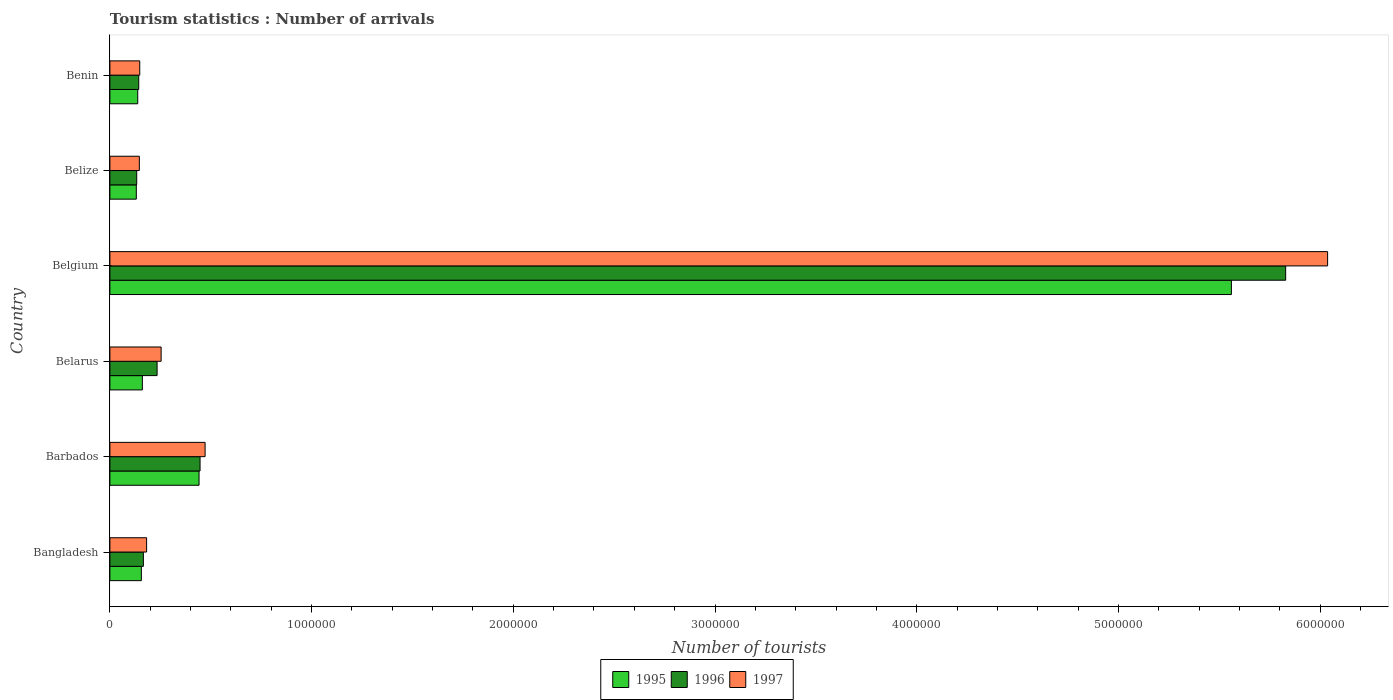How many different coloured bars are there?
Provide a succinct answer. 3. How many groups of bars are there?
Your answer should be compact. 6. Are the number of bars per tick equal to the number of legend labels?
Give a very brief answer. Yes. How many bars are there on the 2nd tick from the top?
Give a very brief answer. 3. What is the label of the 5th group of bars from the top?
Offer a very short reply. Barbados. In how many cases, is the number of bars for a given country not equal to the number of legend labels?
Provide a short and direct response. 0. What is the number of tourist arrivals in 1997 in Benin?
Keep it short and to the point. 1.48e+05. Across all countries, what is the maximum number of tourist arrivals in 1995?
Keep it short and to the point. 5.56e+06. Across all countries, what is the minimum number of tourist arrivals in 1997?
Your answer should be compact. 1.46e+05. In which country was the number of tourist arrivals in 1995 minimum?
Your answer should be very brief. Belize. What is the total number of tourist arrivals in 1996 in the graph?
Your response must be concise. 6.95e+06. What is the difference between the number of tourist arrivals in 1996 in Barbados and that in Belize?
Your answer should be very brief. 3.14e+05. What is the difference between the number of tourist arrivals in 1996 in Bangladesh and the number of tourist arrivals in 1995 in Belgium?
Your answer should be very brief. -5.39e+06. What is the average number of tourist arrivals in 1996 per country?
Ensure brevity in your answer.  1.16e+06. What is the difference between the number of tourist arrivals in 1997 and number of tourist arrivals in 1996 in Belize?
Give a very brief answer. 1.30e+04. In how many countries, is the number of tourist arrivals in 1996 greater than 800000 ?
Provide a short and direct response. 1. What is the ratio of the number of tourist arrivals in 1996 in Bangladesh to that in Belize?
Your response must be concise. 1.25. Is the difference between the number of tourist arrivals in 1997 in Bangladesh and Belarus greater than the difference between the number of tourist arrivals in 1996 in Bangladesh and Belarus?
Offer a terse response. No. What is the difference between the highest and the second highest number of tourist arrivals in 1995?
Your answer should be compact. 5.12e+06. What is the difference between the highest and the lowest number of tourist arrivals in 1997?
Your answer should be very brief. 5.89e+06. In how many countries, is the number of tourist arrivals in 1997 greater than the average number of tourist arrivals in 1997 taken over all countries?
Make the answer very short. 1. Is the sum of the number of tourist arrivals in 1995 in Bangladesh and Belgium greater than the maximum number of tourist arrivals in 1996 across all countries?
Keep it short and to the point. No. What does the 3rd bar from the top in Belgium represents?
Offer a very short reply. 1995. What does the 2nd bar from the bottom in Benin represents?
Make the answer very short. 1996. How many bars are there?
Ensure brevity in your answer.  18. How many countries are there in the graph?
Ensure brevity in your answer.  6. Are the values on the major ticks of X-axis written in scientific E-notation?
Provide a succinct answer. No. Where does the legend appear in the graph?
Make the answer very short. Bottom center. What is the title of the graph?
Provide a short and direct response. Tourism statistics : Number of arrivals. What is the label or title of the X-axis?
Offer a very short reply. Number of tourists. What is the label or title of the Y-axis?
Your answer should be compact. Country. What is the Number of tourists in 1995 in Bangladesh?
Offer a very short reply. 1.56e+05. What is the Number of tourists of 1996 in Bangladesh?
Offer a terse response. 1.66e+05. What is the Number of tourists of 1997 in Bangladesh?
Keep it short and to the point. 1.82e+05. What is the Number of tourists of 1995 in Barbados?
Give a very brief answer. 4.42e+05. What is the Number of tourists of 1996 in Barbados?
Your answer should be very brief. 4.47e+05. What is the Number of tourists of 1997 in Barbados?
Give a very brief answer. 4.72e+05. What is the Number of tourists in 1995 in Belarus?
Provide a succinct answer. 1.61e+05. What is the Number of tourists in 1996 in Belarus?
Your answer should be compact. 2.34e+05. What is the Number of tourists in 1997 in Belarus?
Your answer should be very brief. 2.54e+05. What is the Number of tourists in 1995 in Belgium?
Make the answer very short. 5.56e+06. What is the Number of tourists in 1996 in Belgium?
Your answer should be compact. 5.83e+06. What is the Number of tourists in 1997 in Belgium?
Your response must be concise. 6.04e+06. What is the Number of tourists in 1995 in Belize?
Provide a succinct answer. 1.31e+05. What is the Number of tourists of 1996 in Belize?
Make the answer very short. 1.33e+05. What is the Number of tourists of 1997 in Belize?
Offer a terse response. 1.46e+05. What is the Number of tourists in 1995 in Benin?
Ensure brevity in your answer.  1.38e+05. What is the Number of tourists in 1996 in Benin?
Provide a succinct answer. 1.43e+05. What is the Number of tourists in 1997 in Benin?
Provide a short and direct response. 1.48e+05. Across all countries, what is the maximum Number of tourists of 1995?
Give a very brief answer. 5.56e+06. Across all countries, what is the maximum Number of tourists of 1996?
Your answer should be very brief. 5.83e+06. Across all countries, what is the maximum Number of tourists of 1997?
Make the answer very short. 6.04e+06. Across all countries, what is the minimum Number of tourists of 1995?
Ensure brevity in your answer.  1.31e+05. Across all countries, what is the minimum Number of tourists of 1996?
Provide a short and direct response. 1.33e+05. Across all countries, what is the minimum Number of tourists in 1997?
Provide a succinct answer. 1.46e+05. What is the total Number of tourists in 1995 in the graph?
Your answer should be compact. 6.59e+06. What is the total Number of tourists in 1996 in the graph?
Your response must be concise. 6.95e+06. What is the total Number of tourists in 1997 in the graph?
Your response must be concise. 7.24e+06. What is the difference between the Number of tourists of 1995 in Bangladesh and that in Barbados?
Give a very brief answer. -2.86e+05. What is the difference between the Number of tourists of 1996 in Bangladesh and that in Barbados?
Your answer should be very brief. -2.81e+05. What is the difference between the Number of tourists of 1997 in Bangladesh and that in Barbados?
Ensure brevity in your answer.  -2.90e+05. What is the difference between the Number of tourists of 1995 in Bangladesh and that in Belarus?
Provide a succinct answer. -5000. What is the difference between the Number of tourists of 1996 in Bangladesh and that in Belarus?
Your answer should be very brief. -6.80e+04. What is the difference between the Number of tourists in 1997 in Bangladesh and that in Belarus?
Provide a short and direct response. -7.20e+04. What is the difference between the Number of tourists of 1995 in Bangladesh and that in Belgium?
Give a very brief answer. -5.40e+06. What is the difference between the Number of tourists of 1996 in Bangladesh and that in Belgium?
Keep it short and to the point. -5.66e+06. What is the difference between the Number of tourists in 1997 in Bangladesh and that in Belgium?
Keep it short and to the point. -5.86e+06. What is the difference between the Number of tourists of 1995 in Bangladesh and that in Belize?
Offer a very short reply. 2.50e+04. What is the difference between the Number of tourists in 1996 in Bangladesh and that in Belize?
Your answer should be compact. 3.30e+04. What is the difference between the Number of tourists in 1997 in Bangladesh and that in Belize?
Your response must be concise. 3.60e+04. What is the difference between the Number of tourists of 1995 in Bangladesh and that in Benin?
Keep it short and to the point. 1.80e+04. What is the difference between the Number of tourists of 1996 in Bangladesh and that in Benin?
Provide a succinct answer. 2.30e+04. What is the difference between the Number of tourists of 1997 in Bangladesh and that in Benin?
Provide a short and direct response. 3.40e+04. What is the difference between the Number of tourists of 1995 in Barbados and that in Belarus?
Offer a terse response. 2.81e+05. What is the difference between the Number of tourists of 1996 in Barbados and that in Belarus?
Your answer should be very brief. 2.13e+05. What is the difference between the Number of tourists of 1997 in Barbados and that in Belarus?
Make the answer very short. 2.18e+05. What is the difference between the Number of tourists in 1995 in Barbados and that in Belgium?
Your answer should be compact. -5.12e+06. What is the difference between the Number of tourists in 1996 in Barbados and that in Belgium?
Give a very brief answer. -5.38e+06. What is the difference between the Number of tourists in 1997 in Barbados and that in Belgium?
Your answer should be compact. -5.56e+06. What is the difference between the Number of tourists in 1995 in Barbados and that in Belize?
Your response must be concise. 3.11e+05. What is the difference between the Number of tourists of 1996 in Barbados and that in Belize?
Provide a succinct answer. 3.14e+05. What is the difference between the Number of tourists in 1997 in Barbados and that in Belize?
Your answer should be compact. 3.26e+05. What is the difference between the Number of tourists of 1995 in Barbados and that in Benin?
Your answer should be compact. 3.04e+05. What is the difference between the Number of tourists in 1996 in Barbados and that in Benin?
Give a very brief answer. 3.04e+05. What is the difference between the Number of tourists of 1997 in Barbados and that in Benin?
Provide a succinct answer. 3.24e+05. What is the difference between the Number of tourists in 1995 in Belarus and that in Belgium?
Keep it short and to the point. -5.40e+06. What is the difference between the Number of tourists in 1996 in Belarus and that in Belgium?
Offer a terse response. -5.60e+06. What is the difference between the Number of tourists of 1997 in Belarus and that in Belgium?
Your response must be concise. -5.78e+06. What is the difference between the Number of tourists of 1995 in Belarus and that in Belize?
Your answer should be very brief. 3.00e+04. What is the difference between the Number of tourists in 1996 in Belarus and that in Belize?
Provide a succinct answer. 1.01e+05. What is the difference between the Number of tourists in 1997 in Belarus and that in Belize?
Keep it short and to the point. 1.08e+05. What is the difference between the Number of tourists of 1995 in Belarus and that in Benin?
Keep it short and to the point. 2.30e+04. What is the difference between the Number of tourists in 1996 in Belarus and that in Benin?
Give a very brief answer. 9.10e+04. What is the difference between the Number of tourists of 1997 in Belarus and that in Benin?
Give a very brief answer. 1.06e+05. What is the difference between the Number of tourists of 1995 in Belgium and that in Belize?
Provide a succinct answer. 5.43e+06. What is the difference between the Number of tourists of 1996 in Belgium and that in Belize?
Offer a very short reply. 5.70e+06. What is the difference between the Number of tourists in 1997 in Belgium and that in Belize?
Provide a short and direct response. 5.89e+06. What is the difference between the Number of tourists in 1995 in Belgium and that in Benin?
Provide a short and direct response. 5.42e+06. What is the difference between the Number of tourists in 1996 in Belgium and that in Benin?
Offer a very short reply. 5.69e+06. What is the difference between the Number of tourists of 1997 in Belgium and that in Benin?
Provide a succinct answer. 5.89e+06. What is the difference between the Number of tourists in 1995 in Belize and that in Benin?
Offer a terse response. -7000. What is the difference between the Number of tourists of 1997 in Belize and that in Benin?
Make the answer very short. -2000. What is the difference between the Number of tourists of 1995 in Bangladesh and the Number of tourists of 1996 in Barbados?
Provide a short and direct response. -2.91e+05. What is the difference between the Number of tourists of 1995 in Bangladesh and the Number of tourists of 1997 in Barbados?
Offer a terse response. -3.16e+05. What is the difference between the Number of tourists in 1996 in Bangladesh and the Number of tourists in 1997 in Barbados?
Your response must be concise. -3.06e+05. What is the difference between the Number of tourists of 1995 in Bangladesh and the Number of tourists of 1996 in Belarus?
Offer a terse response. -7.80e+04. What is the difference between the Number of tourists in 1995 in Bangladesh and the Number of tourists in 1997 in Belarus?
Provide a short and direct response. -9.80e+04. What is the difference between the Number of tourists in 1996 in Bangladesh and the Number of tourists in 1997 in Belarus?
Your answer should be very brief. -8.80e+04. What is the difference between the Number of tourists in 1995 in Bangladesh and the Number of tourists in 1996 in Belgium?
Your answer should be very brief. -5.67e+06. What is the difference between the Number of tourists of 1995 in Bangladesh and the Number of tourists of 1997 in Belgium?
Your answer should be compact. -5.88e+06. What is the difference between the Number of tourists in 1996 in Bangladesh and the Number of tourists in 1997 in Belgium?
Your response must be concise. -5.87e+06. What is the difference between the Number of tourists of 1995 in Bangladesh and the Number of tourists of 1996 in Belize?
Keep it short and to the point. 2.30e+04. What is the difference between the Number of tourists of 1995 in Bangladesh and the Number of tourists of 1996 in Benin?
Your answer should be very brief. 1.30e+04. What is the difference between the Number of tourists in 1995 in Bangladesh and the Number of tourists in 1997 in Benin?
Make the answer very short. 8000. What is the difference between the Number of tourists of 1996 in Bangladesh and the Number of tourists of 1997 in Benin?
Your response must be concise. 1.80e+04. What is the difference between the Number of tourists of 1995 in Barbados and the Number of tourists of 1996 in Belarus?
Keep it short and to the point. 2.08e+05. What is the difference between the Number of tourists of 1995 in Barbados and the Number of tourists of 1997 in Belarus?
Your response must be concise. 1.88e+05. What is the difference between the Number of tourists of 1996 in Barbados and the Number of tourists of 1997 in Belarus?
Ensure brevity in your answer.  1.93e+05. What is the difference between the Number of tourists in 1995 in Barbados and the Number of tourists in 1996 in Belgium?
Provide a short and direct response. -5.39e+06. What is the difference between the Number of tourists of 1995 in Barbados and the Number of tourists of 1997 in Belgium?
Provide a short and direct response. -5.60e+06. What is the difference between the Number of tourists of 1996 in Barbados and the Number of tourists of 1997 in Belgium?
Keep it short and to the point. -5.59e+06. What is the difference between the Number of tourists in 1995 in Barbados and the Number of tourists in 1996 in Belize?
Your answer should be compact. 3.09e+05. What is the difference between the Number of tourists in 1995 in Barbados and the Number of tourists in 1997 in Belize?
Give a very brief answer. 2.96e+05. What is the difference between the Number of tourists in 1996 in Barbados and the Number of tourists in 1997 in Belize?
Keep it short and to the point. 3.01e+05. What is the difference between the Number of tourists in 1995 in Barbados and the Number of tourists in 1996 in Benin?
Offer a very short reply. 2.99e+05. What is the difference between the Number of tourists of 1995 in Barbados and the Number of tourists of 1997 in Benin?
Offer a terse response. 2.94e+05. What is the difference between the Number of tourists in 1996 in Barbados and the Number of tourists in 1997 in Benin?
Make the answer very short. 2.99e+05. What is the difference between the Number of tourists of 1995 in Belarus and the Number of tourists of 1996 in Belgium?
Provide a succinct answer. -5.67e+06. What is the difference between the Number of tourists in 1995 in Belarus and the Number of tourists in 1997 in Belgium?
Your answer should be very brief. -5.88e+06. What is the difference between the Number of tourists of 1996 in Belarus and the Number of tourists of 1997 in Belgium?
Your answer should be compact. -5.80e+06. What is the difference between the Number of tourists of 1995 in Belarus and the Number of tourists of 1996 in Belize?
Your response must be concise. 2.80e+04. What is the difference between the Number of tourists in 1995 in Belarus and the Number of tourists in 1997 in Belize?
Provide a short and direct response. 1.50e+04. What is the difference between the Number of tourists of 1996 in Belarus and the Number of tourists of 1997 in Belize?
Give a very brief answer. 8.80e+04. What is the difference between the Number of tourists in 1995 in Belarus and the Number of tourists in 1996 in Benin?
Ensure brevity in your answer.  1.80e+04. What is the difference between the Number of tourists of 1995 in Belarus and the Number of tourists of 1997 in Benin?
Your response must be concise. 1.30e+04. What is the difference between the Number of tourists in 1996 in Belarus and the Number of tourists in 1997 in Benin?
Make the answer very short. 8.60e+04. What is the difference between the Number of tourists of 1995 in Belgium and the Number of tourists of 1996 in Belize?
Your answer should be compact. 5.43e+06. What is the difference between the Number of tourists of 1995 in Belgium and the Number of tourists of 1997 in Belize?
Your response must be concise. 5.41e+06. What is the difference between the Number of tourists of 1996 in Belgium and the Number of tourists of 1997 in Belize?
Provide a succinct answer. 5.68e+06. What is the difference between the Number of tourists in 1995 in Belgium and the Number of tourists in 1996 in Benin?
Your response must be concise. 5.42e+06. What is the difference between the Number of tourists in 1995 in Belgium and the Number of tourists in 1997 in Benin?
Your answer should be very brief. 5.41e+06. What is the difference between the Number of tourists in 1996 in Belgium and the Number of tourists in 1997 in Benin?
Make the answer very short. 5.68e+06. What is the difference between the Number of tourists of 1995 in Belize and the Number of tourists of 1996 in Benin?
Give a very brief answer. -1.20e+04. What is the difference between the Number of tourists of 1995 in Belize and the Number of tourists of 1997 in Benin?
Offer a very short reply. -1.70e+04. What is the difference between the Number of tourists in 1996 in Belize and the Number of tourists in 1997 in Benin?
Offer a very short reply. -1.50e+04. What is the average Number of tourists in 1995 per country?
Keep it short and to the point. 1.10e+06. What is the average Number of tourists in 1996 per country?
Provide a short and direct response. 1.16e+06. What is the average Number of tourists in 1997 per country?
Give a very brief answer. 1.21e+06. What is the difference between the Number of tourists of 1995 and Number of tourists of 1997 in Bangladesh?
Your response must be concise. -2.60e+04. What is the difference between the Number of tourists in 1996 and Number of tourists in 1997 in Bangladesh?
Ensure brevity in your answer.  -1.60e+04. What is the difference between the Number of tourists of 1995 and Number of tourists of 1996 in Barbados?
Your answer should be compact. -5000. What is the difference between the Number of tourists of 1996 and Number of tourists of 1997 in Barbados?
Provide a succinct answer. -2.50e+04. What is the difference between the Number of tourists of 1995 and Number of tourists of 1996 in Belarus?
Give a very brief answer. -7.30e+04. What is the difference between the Number of tourists in 1995 and Number of tourists in 1997 in Belarus?
Offer a very short reply. -9.30e+04. What is the difference between the Number of tourists in 1995 and Number of tourists in 1996 in Belgium?
Ensure brevity in your answer.  -2.69e+05. What is the difference between the Number of tourists of 1995 and Number of tourists of 1997 in Belgium?
Keep it short and to the point. -4.77e+05. What is the difference between the Number of tourists in 1996 and Number of tourists in 1997 in Belgium?
Your answer should be very brief. -2.08e+05. What is the difference between the Number of tourists of 1995 and Number of tourists of 1996 in Belize?
Keep it short and to the point. -2000. What is the difference between the Number of tourists of 1995 and Number of tourists of 1997 in Belize?
Offer a terse response. -1.50e+04. What is the difference between the Number of tourists of 1996 and Number of tourists of 1997 in Belize?
Provide a short and direct response. -1.30e+04. What is the difference between the Number of tourists in 1995 and Number of tourists in 1996 in Benin?
Give a very brief answer. -5000. What is the difference between the Number of tourists of 1995 and Number of tourists of 1997 in Benin?
Your answer should be compact. -10000. What is the difference between the Number of tourists of 1996 and Number of tourists of 1997 in Benin?
Provide a short and direct response. -5000. What is the ratio of the Number of tourists in 1995 in Bangladesh to that in Barbados?
Your answer should be compact. 0.35. What is the ratio of the Number of tourists of 1996 in Bangladesh to that in Barbados?
Give a very brief answer. 0.37. What is the ratio of the Number of tourists in 1997 in Bangladesh to that in Barbados?
Offer a very short reply. 0.39. What is the ratio of the Number of tourists in 1995 in Bangladesh to that in Belarus?
Your answer should be very brief. 0.97. What is the ratio of the Number of tourists of 1996 in Bangladesh to that in Belarus?
Your answer should be very brief. 0.71. What is the ratio of the Number of tourists of 1997 in Bangladesh to that in Belarus?
Ensure brevity in your answer.  0.72. What is the ratio of the Number of tourists in 1995 in Bangladesh to that in Belgium?
Give a very brief answer. 0.03. What is the ratio of the Number of tourists of 1996 in Bangladesh to that in Belgium?
Provide a short and direct response. 0.03. What is the ratio of the Number of tourists of 1997 in Bangladesh to that in Belgium?
Offer a very short reply. 0.03. What is the ratio of the Number of tourists of 1995 in Bangladesh to that in Belize?
Provide a succinct answer. 1.19. What is the ratio of the Number of tourists of 1996 in Bangladesh to that in Belize?
Your answer should be compact. 1.25. What is the ratio of the Number of tourists in 1997 in Bangladesh to that in Belize?
Provide a short and direct response. 1.25. What is the ratio of the Number of tourists in 1995 in Bangladesh to that in Benin?
Ensure brevity in your answer.  1.13. What is the ratio of the Number of tourists in 1996 in Bangladesh to that in Benin?
Give a very brief answer. 1.16. What is the ratio of the Number of tourists in 1997 in Bangladesh to that in Benin?
Make the answer very short. 1.23. What is the ratio of the Number of tourists in 1995 in Barbados to that in Belarus?
Offer a very short reply. 2.75. What is the ratio of the Number of tourists in 1996 in Barbados to that in Belarus?
Give a very brief answer. 1.91. What is the ratio of the Number of tourists of 1997 in Barbados to that in Belarus?
Offer a terse response. 1.86. What is the ratio of the Number of tourists of 1995 in Barbados to that in Belgium?
Offer a terse response. 0.08. What is the ratio of the Number of tourists in 1996 in Barbados to that in Belgium?
Make the answer very short. 0.08. What is the ratio of the Number of tourists of 1997 in Barbados to that in Belgium?
Give a very brief answer. 0.08. What is the ratio of the Number of tourists in 1995 in Barbados to that in Belize?
Your response must be concise. 3.37. What is the ratio of the Number of tourists in 1996 in Barbados to that in Belize?
Your response must be concise. 3.36. What is the ratio of the Number of tourists of 1997 in Barbados to that in Belize?
Your response must be concise. 3.23. What is the ratio of the Number of tourists of 1995 in Barbados to that in Benin?
Offer a terse response. 3.2. What is the ratio of the Number of tourists of 1996 in Barbados to that in Benin?
Offer a very short reply. 3.13. What is the ratio of the Number of tourists in 1997 in Barbados to that in Benin?
Provide a short and direct response. 3.19. What is the ratio of the Number of tourists in 1995 in Belarus to that in Belgium?
Ensure brevity in your answer.  0.03. What is the ratio of the Number of tourists in 1996 in Belarus to that in Belgium?
Offer a very short reply. 0.04. What is the ratio of the Number of tourists of 1997 in Belarus to that in Belgium?
Keep it short and to the point. 0.04. What is the ratio of the Number of tourists in 1995 in Belarus to that in Belize?
Keep it short and to the point. 1.23. What is the ratio of the Number of tourists of 1996 in Belarus to that in Belize?
Your response must be concise. 1.76. What is the ratio of the Number of tourists in 1997 in Belarus to that in Belize?
Give a very brief answer. 1.74. What is the ratio of the Number of tourists of 1995 in Belarus to that in Benin?
Ensure brevity in your answer.  1.17. What is the ratio of the Number of tourists of 1996 in Belarus to that in Benin?
Offer a terse response. 1.64. What is the ratio of the Number of tourists in 1997 in Belarus to that in Benin?
Ensure brevity in your answer.  1.72. What is the ratio of the Number of tourists in 1995 in Belgium to that in Belize?
Provide a succinct answer. 42.44. What is the ratio of the Number of tourists of 1996 in Belgium to that in Belize?
Your answer should be compact. 43.83. What is the ratio of the Number of tourists of 1997 in Belgium to that in Belize?
Keep it short and to the point. 41.35. What is the ratio of the Number of tourists in 1995 in Belgium to that in Benin?
Make the answer very short. 40.29. What is the ratio of the Number of tourists in 1996 in Belgium to that in Benin?
Keep it short and to the point. 40.76. What is the ratio of the Number of tourists of 1997 in Belgium to that in Benin?
Make the answer very short. 40.79. What is the ratio of the Number of tourists in 1995 in Belize to that in Benin?
Make the answer very short. 0.95. What is the ratio of the Number of tourists in 1996 in Belize to that in Benin?
Offer a terse response. 0.93. What is the ratio of the Number of tourists in 1997 in Belize to that in Benin?
Offer a very short reply. 0.99. What is the difference between the highest and the second highest Number of tourists of 1995?
Make the answer very short. 5.12e+06. What is the difference between the highest and the second highest Number of tourists of 1996?
Make the answer very short. 5.38e+06. What is the difference between the highest and the second highest Number of tourists in 1997?
Your response must be concise. 5.56e+06. What is the difference between the highest and the lowest Number of tourists in 1995?
Your answer should be compact. 5.43e+06. What is the difference between the highest and the lowest Number of tourists of 1996?
Make the answer very short. 5.70e+06. What is the difference between the highest and the lowest Number of tourists of 1997?
Provide a short and direct response. 5.89e+06. 